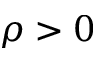<formula> <loc_0><loc_0><loc_500><loc_500>\rho > 0</formula> 